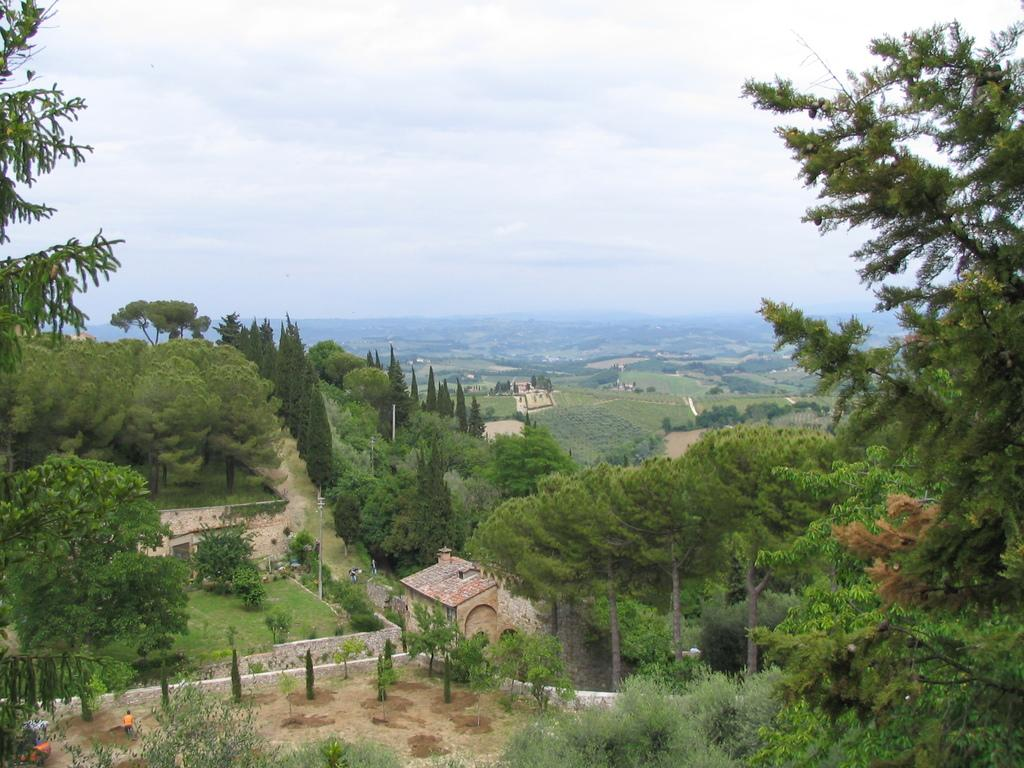What type of structures can be seen in the image? There are houses in the image. What other natural elements are present in the image? There are plants, trees, and the sky visible in the image. Are there any people in the image? Yes, there is a person in the image. What else can be seen in the image besides the houses and natural elements? There are poles in the image. What is the price of the circle in the image? There is no circle present in the image, and therefore no price can be determined. What type of drug is being sold by the person in the image? There is no indication of any drug or transaction in the image; it features houses, plants, trees, a person, poles, and the sky. 